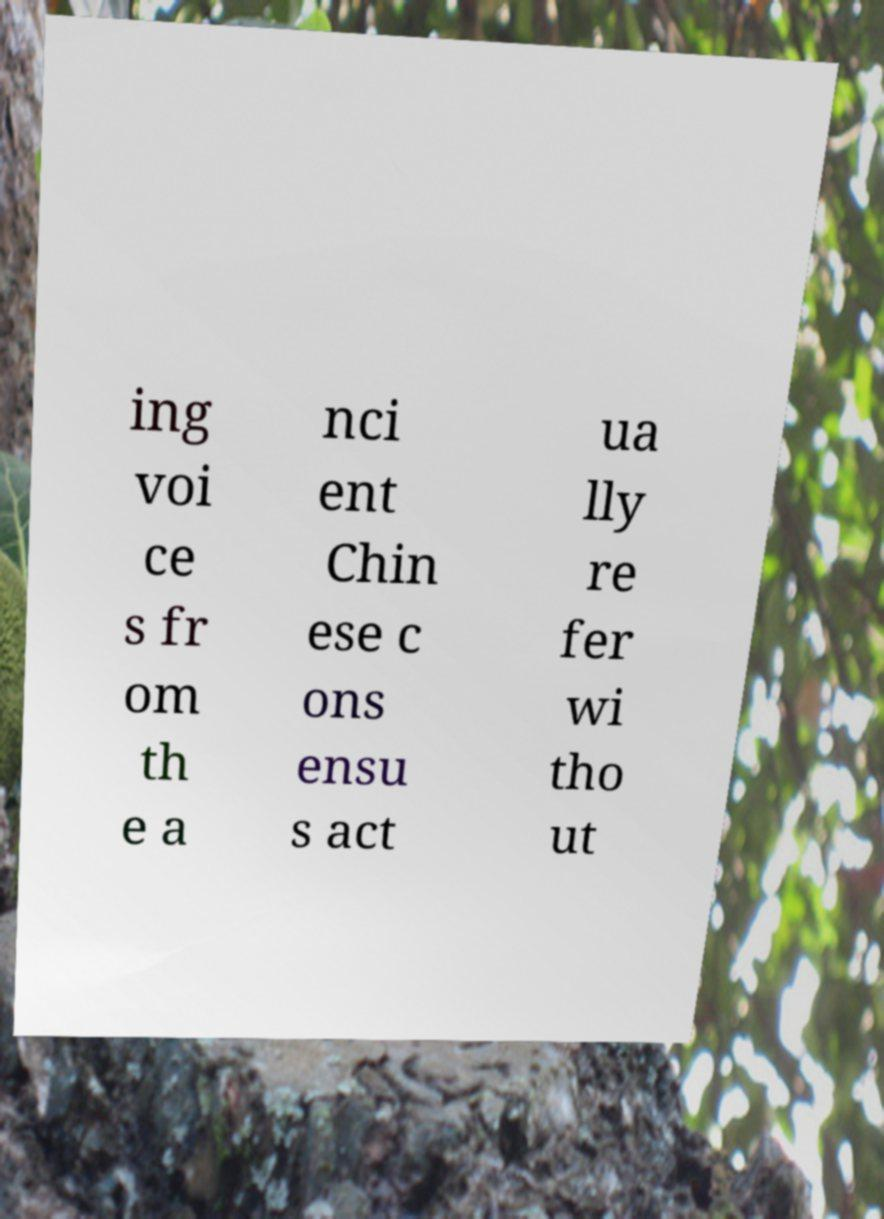What messages or text are displayed in this image? I need them in a readable, typed format. ing voi ce s fr om th e a nci ent Chin ese c ons ensu s act ua lly re fer wi tho ut 